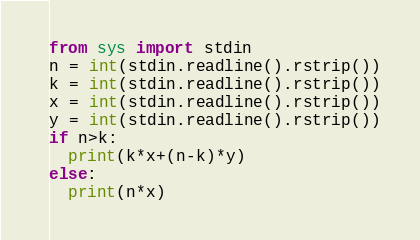Convert code to text. <code><loc_0><loc_0><loc_500><loc_500><_Python_>from sys import stdin
n = int(stdin.readline().rstrip())
k = int(stdin.readline().rstrip())
x = int(stdin.readline().rstrip())
y = int(stdin.readline().rstrip())
if n>k:
  print(k*x+(n-k)*y)
else:
  print(n*x)</code> 